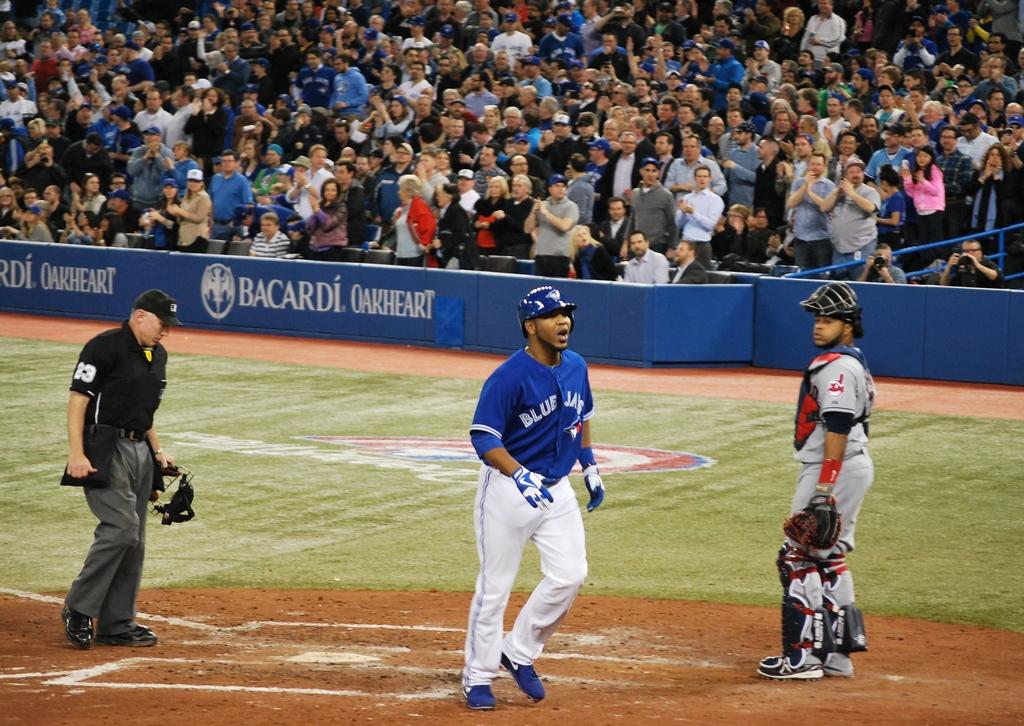What team does he play for?
Ensure brevity in your answer.  Blue jays. Does he play for the blue jay's/?
Provide a succinct answer. Yes. 